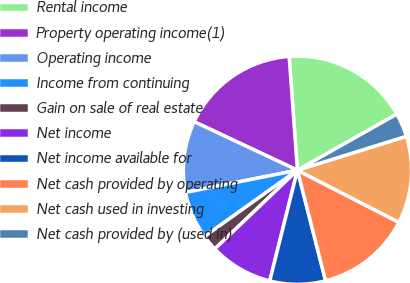<chart> <loc_0><loc_0><loc_500><loc_500><pie_chart><fcel>Rental income<fcel>Property operating income(1)<fcel>Operating income<fcel>Income from continuing<fcel>Gain on sale of real estate<fcel>Net income<fcel>Net income available for<fcel>Net cash provided by operating<fcel>Net cash used in investing<fcel>Net cash provided by (used in)<nl><fcel>17.98%<fcel>16.85%<fcel>10.11%<fcel>6.74%<fcel>2.25%<fcel>8.99%<fcel>7.87%<fcel>13.48%<fcel>12.36%<fcel>3.37%<nl></chart> 